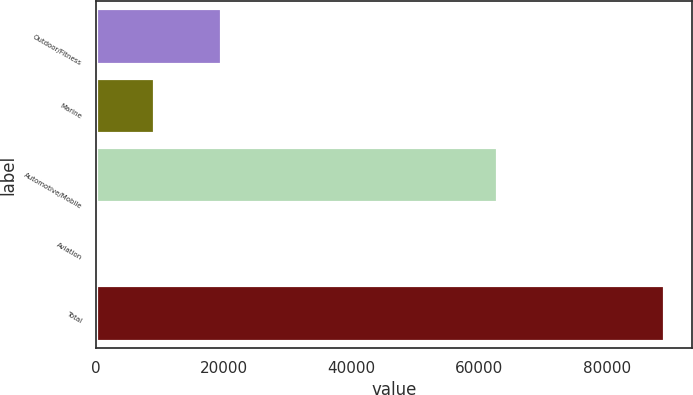Convert chart to OTSL. <chart><loc_0><loc_0><loc_500><loc_500><bar_chart><fcel>Outdoor/Fitness<fcel>Marine<fcel>Automotive/Mobile<fcel>Aviation<fcel>Total<nl><fcel>19613<fcel>9167.2<fcel>62815<fcel>309<fcel>88891<nl></chart> 